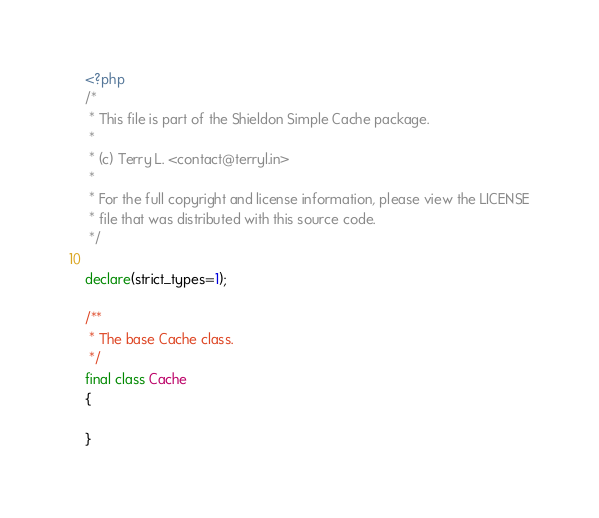<code> <loc_0><loc_0><loc_500><loc_500><_PHP_><?php
/*
 * This file is part of the Shieldon Simple Cache package.
 *
 * (c) Terry L. <contact@terryl.in>
 *
 * For the full copyright and license information, please view the LICENSE
 * file that was distributed with this source code.
 */

declare(strict_types=1);

/**
 * The base Cache class.
 */
final class Cache
{

}</code> 